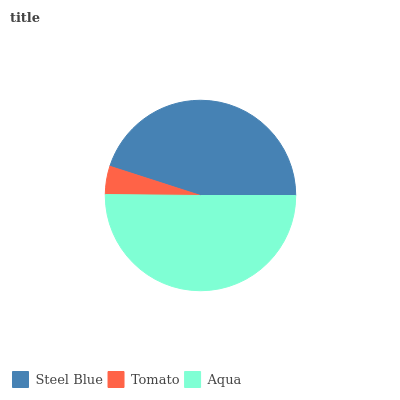Is Tomato the minimum?
Answer yes or no. Yes. Is Aqua the maximum?
Answer yes or no. Yes. Is Aqua the minimum?
Answer yes or no. No. Is Tomato the maximum?
Answer yes or no. No. Is Aqua greater than Tomato?
Answer yes or no. Yes. Is Tomato less than Aqua?
Answer yes or no. Yes. Is Tomato greater than Aqua?
Answer yes or no. No. Is Aqua less than Tomato?
Answer yes or no. No. Is Steel Blue the high median?
Answer yes or no. Yes. Is Steel Blue the low median?
Answer yes or no. Yes. Is Aqua the high median?
Answer yes or no. No. Is Tomato the low median?
Answer yes or no. No. 